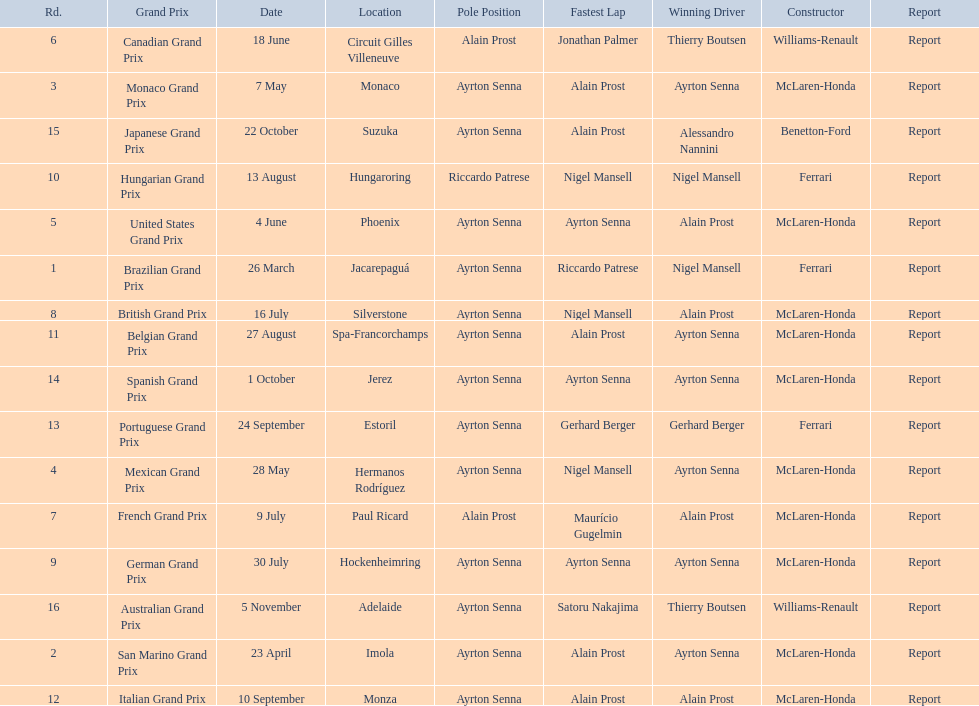What are all of the grand prix run in the 1989 formula one season? Brazilian Grand Prix, San Marino Grand Prix, Monaco Grand Prix, Mexican Grand Prix, United States Grand Prix, Canadian Grand Prix, French Grand Prix, British Grand Prix, German Grand Prix, Hungarian Grand Prix, Belgian Grand Prix, Italian Grand Prix, Portuguese Grand Prix, Spanish Grand Prix, Japanese Grand Prix, Australian Grand Prix. Of those 1989 formula one grand prix, which were run in october? Spanish Grand Prix, Japanese Grand Prix, Australian Grand Prix. Of those 1989 formula one grand prix run in october, which was the only one to be won by benetton-ford? Japanese Grand Prix. 